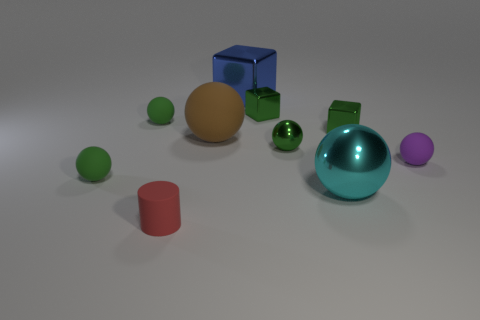Are any yellow cylinders visible?
Offer a terse response. No. There is a tiny rubber object that is on the right side of the red cylinder that is to the left of the big blue metal object that is behind the large matte sphere; what color is it?
Give a very brief answer. Purple. Are there any cubes left of the green matte thing that is behind the brown sphere?
Offer a terse response. No. Does the metallic sphere in front of the small purple thing have the same color as the tiny sphere that is in front of the purple rubber sphere?
Give a very brief answer. No. How many blue things have the same size as the brown rubber sphere?
Your answer should be compact. 1. Does the green ball right of the red cylinder have the same size as the tiny rubber cylinder?
Your response must be concise. Yes. The tiny red matte thing is what shape?
Ensure brevity in your answer.  Cylinder. Are the cyan sphere in front of the big blue cube and the brown sphere made of the same material?
Offer a terse response. No. Are there any cylinders that have the same color as the big rubber ball?
Provide a short and direct response. No. There is a tiny rubber thing behind the small purple rubber thing; does it have the same shape as the small rubber thing that is on the right side of the large blue cube?
Your answer should be compact. Yes. 